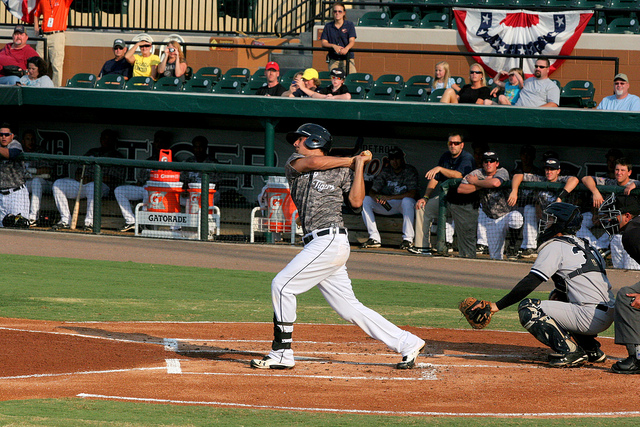<image>Where is the Dayton Daily News ad? It is unknown where the Dayton Daily News ad is. It is not in the picture. Where is the Dayton Daily News ad? It is unknown where the Dayton Daily News ad is located in the image. It is not pictured. 